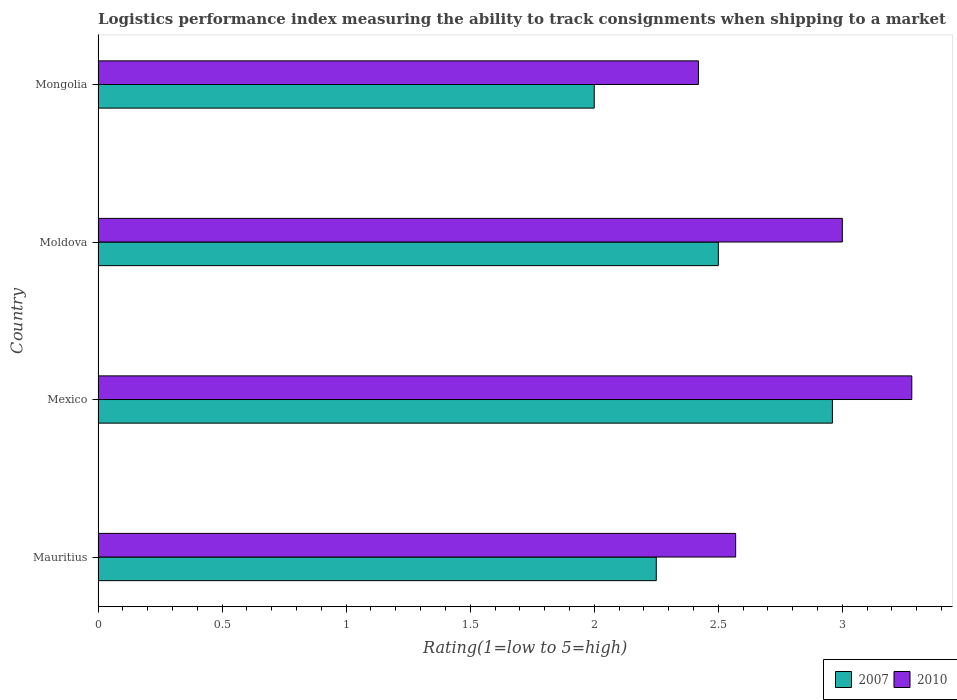How many different coloured bars are there?
Give a very brief answer. 2. How many groups of bars are there?
Offer a very short reply. 4. How many bars are there on the 1st tick from the top?
Your response must be concise. 2. How many bars are there on the 2nd tick from the bottom?
Ensure brevity in your answer.  2. What is the label of the 3rd group of bars from the top?
Make the answer very short. Mexico. What is the Logistic performance index in 2007 in Mauritius?
Offer a terse response. 2.25. Across all countries, what is the maximum Logistic performance index in 2007?
Your answer should be very brief. 2.96. Across all countries, what is the minimum Logistic performance index in 2007?
Provide a succinct answer. 2. In which country was the Logistic performance index in 2010 minimum?
Make the answer very short. Mongolia. What is the total Logistic performance index in 2010 in the graph?
Your answer should be compact. 11.27. What is the difference between the Logistic performance index in 2010 in Moldova and that in Mongolia?
Provide a short and direct response. 0.58. What is the difference between the Logistic performance index in 2010 in Mexico and the Logistic performance index in 2007 in Moldova?
Keep it short and to the point. 0.78. What is the average Logistic performance index in 2010 per country?
Offer a terse response. 2.82. What is the difference between the Logistic performance index in 2007 and Logistic performance index in 2010 in Mexico?
Provide a short and direct response. -0.32. In how many countries, is the Logistic performance index in 2007 greater than 0.5 ?
Ensure brevity in your answer.  4. What is the ratio of the Logistic performance index in 2010 in Mexico to that in Moldova?
Keep it short and to the point. 1.09. Is the difference between the Logistic performance index in 2007 in Mexico and Moldova greater than the difference between the Logistic performance index in 2010 in Mexico and Moldova?
Provide a succinct answer. Yes. What is the difference between the highest and the second highest Logistic performance index in 2007?
Keep it short and to the point. 0.46. Is the sum of the Logistic performance index in 2007 in Mauritius and Moldova greater than the maximum Logistic performance index in 2010 across all countries?
Provide a short and direct response. Yes. What does the 2nd bar from the bottom in Mexico represents?
Give a very brief answer. 2010. Are all the bars in the graph horizontal?
Provide a succinct answer. Yes. Are the values on the major ticks of X-axis written in scientific E-notation?
Make the answer very short. No. Where does the legend appear in the graph?
Give a very brief answer. Bottom right. How many legend labels are there?
Keep it short and to the point. 2. How are the legend labels stacked?
Your response must be concise. Horizontal. What is the title of the graph?
Offer a terse response. Logistics performance index measuring the ability to track consignments when shipping to a market. What is the label or title of the X-axis?
Ensure brevity in your answer.  Rating(1=low to 5=high). What is the Rating(1=low to 5=high) of 2007 in Mauritius?
Give a very brief answer. 2.25. What is the Rating(1=low to 5=high) in 2010 in Mauritius?
Give a very brief answer. 2.57. What is the Rating(1=low to 5=high) of 2007 in Mexico?
Provide a short and direct response. 2.96. What is the Rating(1=low to 5=high) of 2010 in Mexico?
Provide a short and direct response. 3.28. What is the Rating(1=low to 5=high) of 2007 in Moldova?
Provide a short and direct response. 2.5. What is the Rating(1=low to 5=high) of 2007 in Mongolia?
Your response must be concise. 2. What is the Rating(1=low to 5=high) in 2010 in Mongolia?
Your answer should be compact. 2.42. Across all countries, what is the maximum Rating(1=low to 5=high) in 2007?
Your response must be concise. 2.96. Across all countries, what is the maximum Rating(1=low to 5=high) in 2010?
Provide a short and direct response. 3.28. Across all countries, what is the minimum Rating(1=low to 5=high) in 2007?
Offer a terse response. 2. Across all countries, what is the minimum Rating(1=low to 5=high) of 2010?
Provide a short and direct response. 2.42. What is the total Rating(1=low to 5=high) in 2007 in the graph?
Your response must be concise. 9.71. What is the total Rating(1=low to 5=high) of 2010 in the graph?
Make the answer very short. 11.27. What is the difference between the Rating(1=low to 5=high) of 2007 in Mauritius and that in Mexico?
Keep it short and to the point. -0.71. What is the difference between the Rating(1=low to 5=high) in 2010 in Mauritius and that in Mexico?
Provide a short and direct response. -0.71. What is the difference between the Rating(1=low to 5=high) of 2010 in Mauritius and that in Moldova?
Give a very brief answer. -0.43. What is the difference between the Rating(1=low to 5=high) in 2007 in Mauritius and that in Mongolia?
Provide a succinct answer. 0.25. What is the difference between the Rating(1=low to 5=high) in 2010 in Mauritius and that in Mongolia?
Keep it short and to the point. 0.15. What is the difference between the Rating(1=low to 5=high) of 2007 in Mexico and that in Moldova?
Ensure brevity in your answer.  0.46. What is the difference between the Rating(1=low to 5=high) in 2010 in Mexico and that in Moldova?
Ensure brevity in your answer.  0.28. What is the difference between the Rating(1=low to 5=high) in 2010 in Mexico and that in Mongolia?
Give a very brief answer. 0.86. What is the difference between the Rating(1=low to 5=high) in 2007 in Moldova and that in Mongolia?
Provide a short and direct response. 0.5. What is the difference between the Rating(1=low to 5=high) of 2010 in Moldova and that in Mongolia?
Give a very brief answer. 0.58. What is the difference between the Rating(1=low to 5=high) in 2007 in Mauritius and the Rating(1=low to 5=high) in 2010 in Mexico?
Offer a very short reply. -1.03. What is the difference between the Rating(1=low to 5=high) in 2007 in Mauritius and the Rating(1=low to 5=high) in 2010 in Moldova?
Offer a terse response. -0.75. What is the difference between the Rating(1=low to 5=high) in 2007 in Mauritius and the Rating(1=low to 5=high) in 2010 in Mongolia?
Offer a very short reply. -0.17. What is the difference between the Rating(1=low to 5=high) of 2007 in Mexico and the Rating(1=low to 5=high) of 2010 in Moldova?
Your answer should be compact. -0.04. What is the difference between the Rating(1=low to 5=high) in 2007 in Mexico and the Rating(1=low to 5=high) in 2010 in Mongolia?
Provide a succinct answer. 0.54. What is the average Rating(1=low to 5=high) of 2007 per country?
Offer a terse response. 2.43. What is the average Rating(1=low to 5=high) in 2010 per country?
Offer a terse response. 2.82. What is the difference between the Rating(1=low to 5=high) of 2007 and Rating(1=low to 5=high) of 2010 in Mauritius?
Give a very brief answer. -0.32. What is the difference between the Rating(1=low to 5=high) of 2007 and Rating(1=low to 5=high) of 2010 in Mexico?
Your response must be concise. -0.32. What is the difference between the Rating(1=low to 5=high) of 2007 and Rating(1=low to 5=high) of 2010 in Mongolia?
Provide a succinct answer. -0.42. What is the ratio of the Rating(1=low to 5=high) in 2007 in Mauritius to that in Mexico?
Your answer should be compact. 0.76. What is the ratio of the Rating(1=low to 5=high) in 2010 in Mauritius to that in Mexico?
Give a very brief answer. 0.78. What is the ratio of the Rating(1=low to 5=high) of 2007 in Mauritius to that in Moldova?
Your response must be concise. 0.9. What is the ratio of the Rating(1=low to 5=high) in 2010 in Mauritius to that in Moldova?
Keep it short and to the point. 0.86. What is the ratio of the Rating(1=low to 5=high) of 2007 in Mauritius to that in Mongolia?
Offer a very short reply. 1.12. What is the ratio of the Rating(1=low to 5=high) in 2010 in Mauritius to that in Mongolia?
Ensure brevity in your answer.  1.06. What is the ratio of the Rating(1=low to 5=high) in 2007 in Mexico to that in Moldova?
Keep it short and to the point. 1.18. What is the ratio of the Rating(1=low to 5=high) of 2010 in Mexico to that in Moldova?
Provide a short and direct response. 1.09. What is the ratio of the Rating(1=low to 5=high) of 2007 in Mexico to that in Mongolia?
Your answer should be compact. 1.48. What is the ratio of the Rating(1=low to 5=high) of 2010 in Mexico to that in Mongolia?
Provide a succinct answer. 1.36. What is the ratio of the Rating(1=low to 5=high) of 2010 in Moldova to that in Mongolia?
Your response must be concise. 1.24. What is the difference between the highest and the second highest Rating(1=low to 5=high) of 2007?
Offer a terse response. 0.46. What is the difference between the highest and the second highest Rating(1=low to 5=high) in 2010?
Your response must be concise. 0.28. What is the difference between the highest and the lowest Rating(1=low to 5=high) in 2007?
Provide a short and direct response. 0.96. What is the difference between the highest and the lowest Rating(1=low to 5=high) of 2010?
Ensure brevity in your answer.  0.86. 